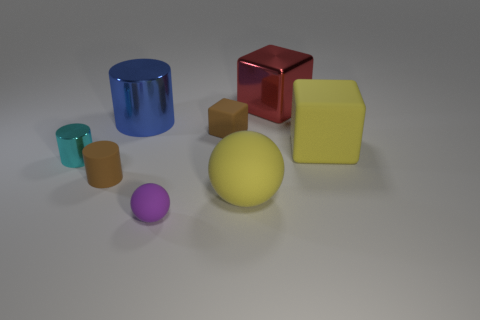Add 2 tiny purple balls. How many objects exist? 10 Subtract all cyan metal cylinders. How many cylinders are left? 2 Subtract 1 balls. How many balls are left? 1 Subtract all cubes. How many objects are left? 5 Subtract all brown cylinders. How many cylinders are left? 2 Subtract 0 purple cubes. How many objects are left? 8 Subtract all cyan cylinders. Subtract all yellow blocks. How many cylinders are left? 2 Subtract all cyan metal cylinders. Subtract all yellow spheres. How many objects are left? 6 Add 6 red things. How many red things are left? 7 Add 5 purple things. How many purple things exist? 6 